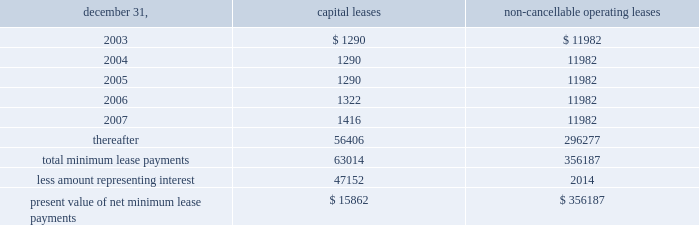N o t e s t o c o n s o l i d a t e d f i n a n c i a l s t a t e m e n t s ( c o n t i n u e d ) the realization of this investment gain ( $ 5624 net of the award ) .
This award , which will be paid out over a three-year period , is presented as deferred compensation award on the balance sheet .
As of december 31 , 2002 , $ 1504 had been paid against this compensation award .
401 ( k ) plan during august 1997 , the company implemented a 401 ( k ) savings/retirement plan ( the 201c401 ( k ) plan 201d ) to cover eligible employees of the company and any designated affiliate .
The 401 ( k ) plan permits eligible employees of the company to defer up to 15% ( 15 % ) of their annual compensation , subject to cer- tain limitations imposed by the code .
The employees 2019 elec- tive deferrals are immediately vested and non-forfeitable upon contribution to the 401 ( k ) plan .
During 2000 , the company amended its 401 ( k ) plan to include a matching contribution , subject to erisa limitations , equal to 50% ( 50 % ) of the first 4% ( 4 % ) of annual compensation deferred by an employee .
For the years ended december 31 , 2002 , 2001 and 2000 , the company made matching contributions of $ 140 , $ 116 and $ 54 , respectively .
18 .
Commitments and contingencies the company and the operating partnership are not presently involved in any material litigation nor , to their knowledge , is any material litigation threatened against them or their properties , other than routine litigation arising in the ordinary course of business .
Management believes the costs , if any , incurred by the company and the operating partnership related to this litigation will not materially affect the financial position , operating results or liquidity of the company and the operating partnership .
On october 24 , 2001 , an accident occurred at 215 park avenue south , a property which the company manages , but does not own .
Personal injury claims have been filed against the company and others by 11 persons .
The company believes that there is sufficient insurance coverage to cover the cost of such claims , as well as any other personal injury or property claims which may arise .
The company has entered into employment agreements with certain executives .
Six executives have employment agreements which expire between november 2003 and december 2007 .
The cash based compensation associated with these employment agreements totals approximately $ 2125 for 2003 .
During march 1998 , the company acquired an operating sub-leasehold position at 420 lexington avenue .
The oper- ating sub-leasehold position requires annual ground lease payments totaling $ 6000 and sub-leasehold position pay- ments totaling $ 1100 ( excluding an operating sub-lease position purchased january 1999 ) .
The ground lease and sub-leasehold positions expire 2008 .
The company may extend the positions through 2029 at market rents .
The property located at 1140 avenue of the americas operates under a net ground lease ( $ 348 annually ) with a term expiration date of 2016 and with an option to renew for an additional 50 years .
The property located at 711 third avenue operates under an operating sub-lease which expires in 2083 .
Under the sub- lease , the company is responsible for ground rent payments of $ 1600 annually which increased to $ 3100 in july 2001 and will continue for the next ten years .
The ground rent is reset after year ten based on the estimated fair market value of the property .
In april 1988 , the sl green predecessor entered into a lease agreement for property at 673 first avenue in new york city , which has been capitalized for financial statement purposes .
Land was estimated to be approximately 70% ( 70 % ) of the fair market value of the property .
The portion of the lease attributed to land is classified as an operating lease and the remainder as a capital lease .
The initial lease term is 49 years with an option for an additional 26 years .
Beginning in lease years 11 and 25 , the lessor is entitled to additional rent as defined by the lease agreement .
The company continues to lease the 673 first avenue prop- erty which has been classified as a capital lease with a cost basis of $ 12208 and cumulative amortization of $ 3579 and $ 3306 at december 31 , 2002 and 2001 , respectively .
The fol- lowing is a schedule of future minimum lease payments under capital leases and noncancellable operating leases with initial terms in excess of one year as of december 31 , 2002 .
Non-cancellable operating december 31 , capital leases leases .
19 .
Financial instruments : derivatives and hedging financial accounting standards board 2019s statement no .
133 , 201caccounting for derivative instruments and hedging activities , 201d ( 201csfas 133 201d ) which became effective january 1 , 2001 requires the company to recognize all derivatives on the balance sheet at fair value .
Derivatives that are not hedges must be adjusted to fair value through income .
If a derivative is a hedge , depending on the nature of the hedge , f i f t y - t w o s l g r e e n r e a l t y c o r p . .
For the 673 first avenue property which has been classified as a capital lease , what percent of the basis was amortized in the year december 31 , 2002? 
Computations: (3579 / 12208)
Answer: 0.29317. 